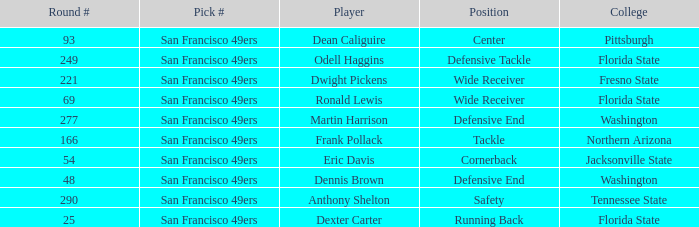What is the College with a Round # that is 290? Tennessee State. 